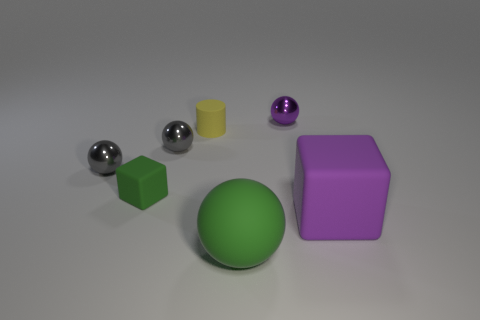Are there any other things that have the same material as the tiny yellow cylinder?
Offer a terse response. Yes. What shape is the small matte object in front of the yellow thing?
Your answer should be compact. Cube. Are there any green rubber objects that are behind the sphere in front of the matte thing right of the large green rubber sphere?
Offer a terse response. Yes. Is there any other thing that has the same shape as the tiny green rubber object?
Your response must be concise. Yes. Are any green spheres visible?
Your response must be concise. Yes. Do the purple object in front of the purple ball and the small ball that is behind the yellow matte cylinder have the same material?
Your answer should be compact. No. What size is the purple thing that is in front of the metallic ball right of the ball in front of the purple rubber block?
Ensure brevity in your answer.  Large. How many objects are the same material as the purple ball?
Ensure brevity in your answer.  2. Is the number of yellow matte objects less than the number of big blue blocks?
Offer a terse response. No. There is another object that is the same shape as the large purple matte thing; what size is it?
Provide a short and direct response. Small. 